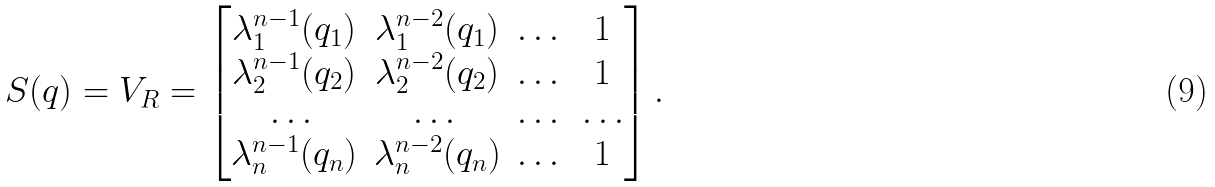<formula> <loc_0><loc_0><loc_500><loc_500>S ( q ) = V _ { R } = \begin{bmatrix} \lambda _ { 1 } ^ { n - 1 } ( q _ { 1 } ) & \lambda _ { 1 } ^ { n - 2 } ( q _ { 1 } ) & \dots & 1 \\ \lambda _ { 2 } ^ { n - 1 } ( q _ { 2 } ) & \lambda _ { 2 } ^ { n - 2 } ( q _ { 2 } ) & \dots & 1 \\ \dots & \dots & \dots & \dots \\ \lambda _ { n } ^ { n - 1 } ( q _ { n } ) & \lambda _ { n } ^ { n - 2 } ( q _ { n } ) & \dots & 1 \end{bmatrix} .</formula> 